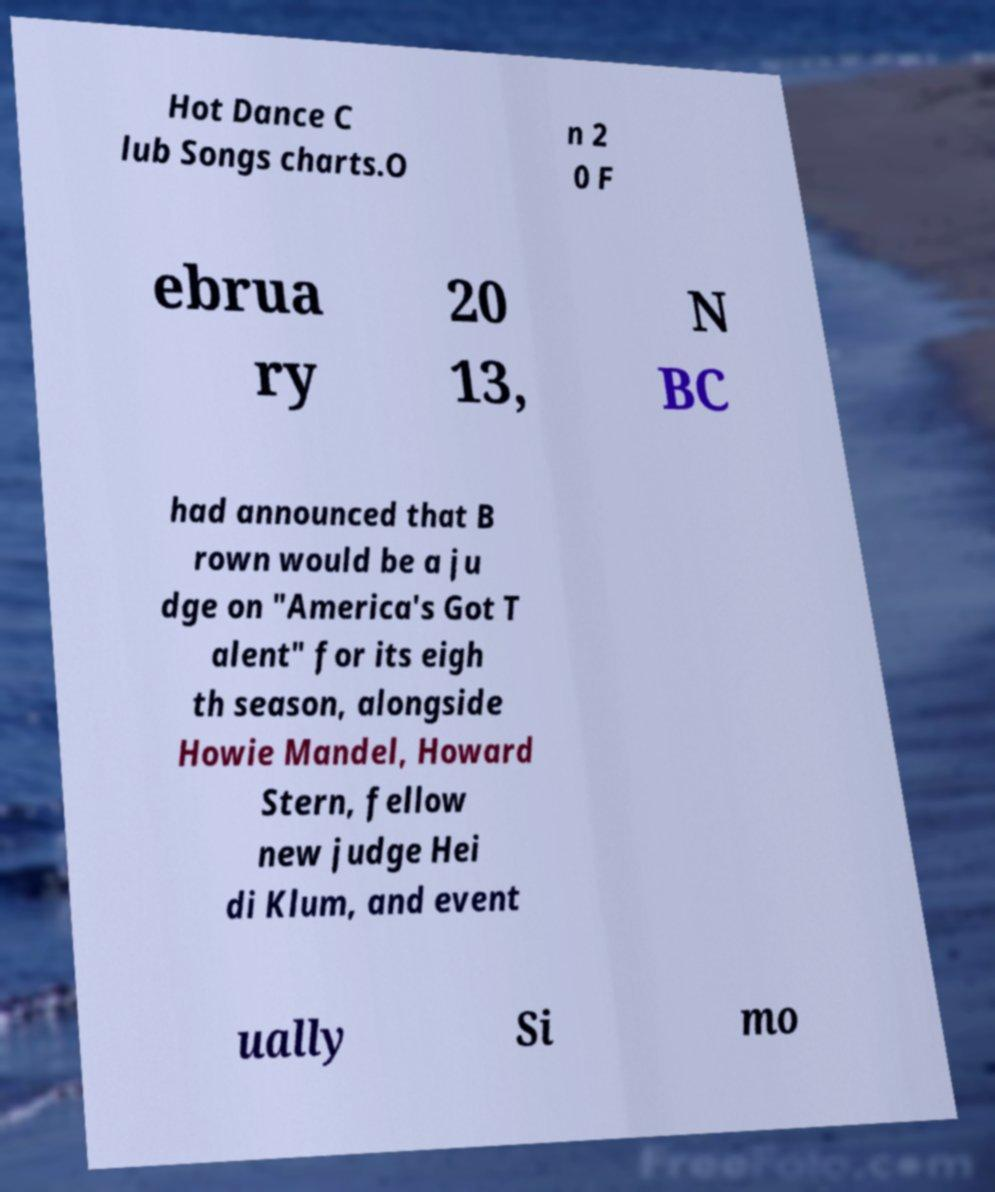Please read and relay the text visible in this image. What does it say? Hot Dance C lub Songs charts.O n 2 0 F ebrua ry 20 13, N BC had announced that B rown would be a ju dge on "America's Got T alent" for its eigh th season, alongside Howie Mandel, Howard Stern, fellow new judge Hei di Klum, and event ually Si mo 